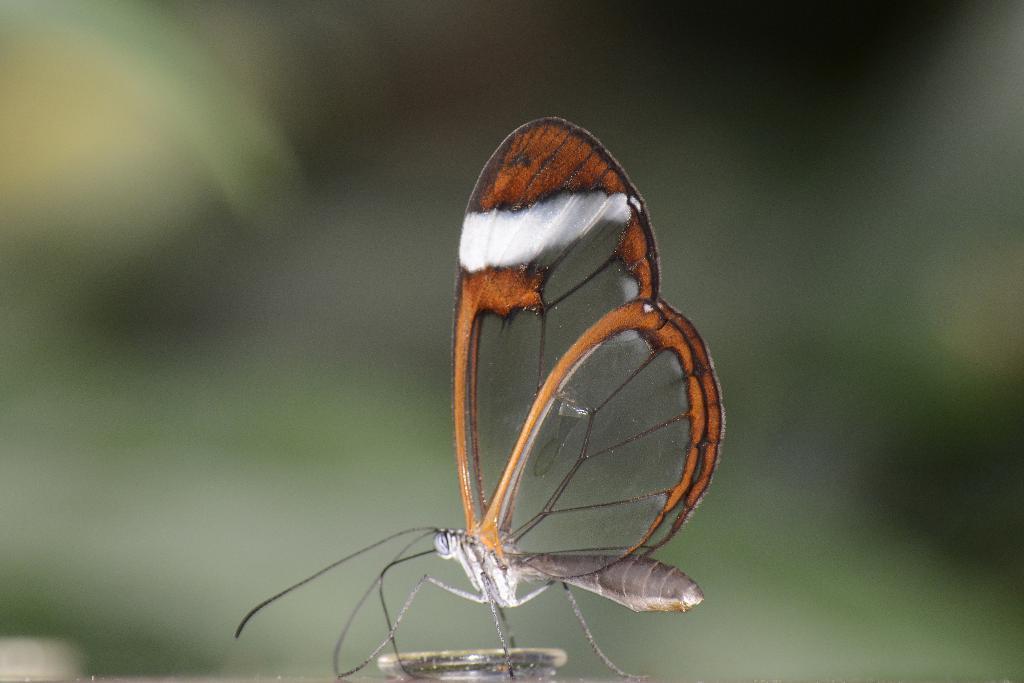Describe this image in one or two sentences. In this image I can see a butterfly which is black, orange, white and ash in color. I can see the blurry background which is green and black in color. 